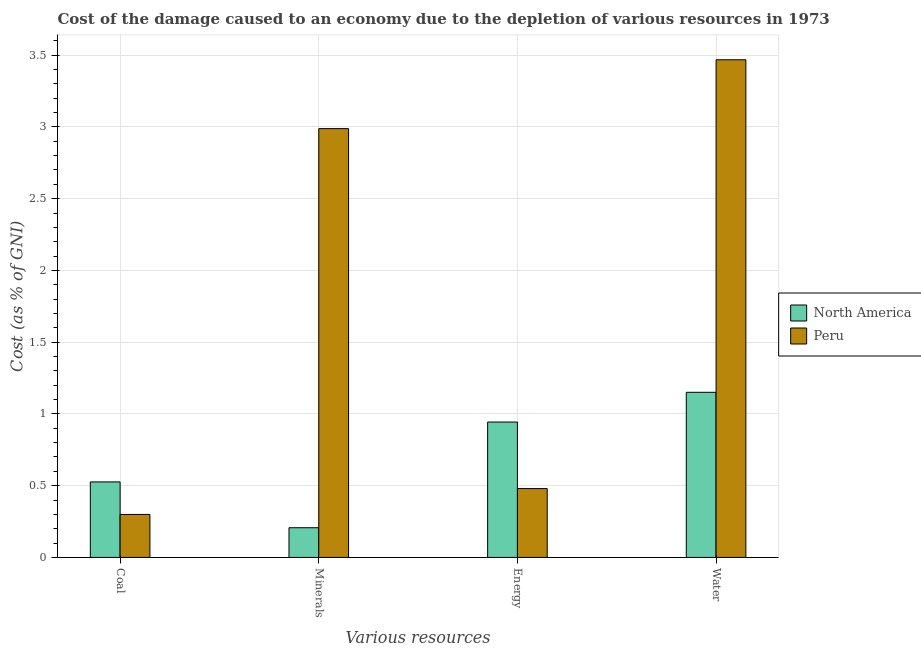How many groups of bars are there?
Provide a short and direct response. 4. Are the number of bars per tick equal to the number of legend labels?
Make the answer very short. Yes. Are the number of bars on each tick of the X-axis equal?
Make the answer very short. Yes. How many bars are there on the 2nd tick from the left?
Offer a terse response. 2. How many bars are there on the 4th tick from the right?
Your response must be concise. 2. What is the label of the 4th group of bars from the left?
Your answer should be compact. Water. What is the cost of damage due to depletion of coal in Peru?
Provide a short and direct response. 0.3. Across all countries, what is the maximum cost of damage due to depletion of minerals?
Ensure brevity in your answer.  2.99. Across all countries, what is the minimum cost of damage due to depletion of minerals?
Provide a succinct answer. 0.21. In which country was the cost of damage due to depletion of energy maximum?
Give a very brief answer. North America. In which country was the cost of damage due to depletion of energy minimum?
Your answer should be very brief. Peru. What is the total cost of damage due to depletion of coal in the graph?
Offer a very short reply. 0.83. What is the difference between the cost of damage due to depletion of energy in North America and that in Peru?
Give a very brief answer. 0.46. What is the difference between the cost of damage due to depletion of minerals in North America and the cost of damage due to depletion of energy in Peru?
Your response must be concise. -0.27. What is the average cost of damage due to depletion of coal per country?
Offer a terse response. 0.41. What is the difference between the cost of damage due to depletion of energy and cost of damage due to depletion of water in North America?
Offer a terse response. -0.21. What is the ratio of the cost of damage due to depletion of energy in North America to that in Peru?
Provide a succinct answer. 1.97. Is the cost of damage due to depletion of coal in North America less than that in Peru?
Give a very brief answer. No. What is the difference between the highest and the second highest cost of damage due to depletion of coal?
Ensure brevity in your answer.  0.23. What is the difference between the highest and the lowest cost of damage due to depletion of coal?
Provide a succinct answer. 0.23. Is the sum of the cost of damage due to depletion of minerals in Peru and North America greater than the maximum cost of damage due to depletion of coal across all countries?
Provide a short and direct response. Yes. Is it the case that in every country, the sum of the cost of damage due to depletion of minerals and cost of damage due to depletion of coal is greater than the sum of cost of damage due to depletion of energy and cost of damage due to depletion of water?
Make the answer very short. No. What does the 2nd bar from the left in Energy represents?
Make the answer very short. Peru. Are the values on the major ticks of Y-axis written in scientific E-notation?
Provide a succinct answer. No. Where does the legend appear in the graph?
Your response must be concise. Center right. How many legend labels are there?
Keep it short and to the point. 2. What is the title of the graph?
Your answer should be very brief. Cost of the damage caused to an economy due to the depletion of various resources in 1973 . Does "Turks and Caicos Islands" appear as one of the legend labels in the graph?
Keep it short and to the point. No. What is the label or title of the X-axis?
Make the answer very short. Various resources. What is the label or title of the Y-axis?
Give a very brief answer. Cost (as % of GNI). What is the Cost (as % of GNI) in North America in Coal?
Ensure brevity in your answer.  0.53. What is the Cost (as % of GNI) in Peru in Coal?
Provide a succinct answer. 0.3. What is the Cost (as % of GNI) of North America in Minerals?
Give a very brief answer. 0.21. What is the Cost (as % of GNI) in Peru in Minerals?
Make the answer very short. 2.99. What is the Cost (as % of GNI) in North America in Energy?
Your answer should be compact. 0.94. What is the Cost (as % of GNI) of Peru in Energy?
Give a very brief answer. 0.48. What is the Cost (as % of GNI) in North America in Water?
Your response must be concise. 1.15. What is the Cost (as % of GNI) of Peru in Water?
Give a very brief answer. 3.47. Across all Various resources, what is the maximum Cost (as % of GNI) in North America?
Keep it short and to the point. 1.15. Across all Various resources, what is the maximum Cost (as % of GNI) in Peru?
Keep it short and to the point. 3.47. Across all Various resources, what is the minimum Cost (as % of GNI) in North America?
Your answer should be very brief. 0.21. Across all Various resources, what is the minimum Cost (as % of GNI) of Peru?
Give a very brief answer. 0.3. What is the total Cost (as % of GNI) of North America in the graph?
Ensure brevity in your answer.  2.83. What is the total Cost (as % of GNI) in Peru in the graph?
Give a very brief answer. 7.24. What is the difference between the Cost (as % of GNI) of North America in Coal and that in Minerals?
Keep it short and to the point. 0.32. What is the difference between the Cost (as % of GNI) in Peru in Coal and that in Minerals?
Keep it short and to the point. -2.69. What is the difference between the Cost (as % of GNI) of North America in Coal and that in Energy?
Provide a succinct answer. -0.42. What is the difference between the Cost (as % of GNI) of Peru in Coal and that in Energy?
Offer a very short reply. -0.18. What is the difference between the Cost (as % of GNI) in North America in Coal and that in Water?
Make the answer very short. -0.62. What is the difference between the Cost (as % of GNI) of Peru in Coal and that in Water?
Provide a short and direct response. -3.17. What is the difference between the Cost (as % of GNI) in North America in Minerals and that in Energy?
Your answer should be very brief. -0.74. What is the difference between the Cost (as % of GNI) in Peru in Minerals and that in Energy?
Offer a very short reply. 2.51. What is the difference between the Cost (as % of GNI) of North America in Minerals and that in Water?
Make the answer very short. -0.94. What is the difference between the Cost (as % of GNI) in Peru in Minerals and that in Water?
Offer a terse response. -0.48. What is the difference between the Cost (as % of GNI) of North America in Energy and that in Water?
Your response must be concise. -0.21. What is the difference between the Cost (as % of GNI) of Peru in Energy and that in Water?
Offer a terse response. -2.99. What is the difference between the Cost (as % of GNI) of North America in Coal and the Cost (as % of GNI) of Peru in Minerals?
Make the answer very short. -2.46. What is the difference between the Cost (as % of GNI) of North America in Coal and the Cost (as % of GNI) of Peru in Energy?
Make the answer very short. 0.05. What is the difference between the Cost (as % of GNI) of North America in Coal and the Cost (as % of GNI) of Peru in Water?
Your response must be concise. -2.94. What is the difference between the Cost (as % of GNI) of North America in Minerals and the Cost (as % of GNI) of Peru in Energy?
Offer a very short reply. -0.27. What is the difference between the Cost (as % of GNI) in North America in Minerals and the Cost (as % of GNI) in Peru in Water?
Offer a terse response. -3.26. What is the difference between the Cost (as % of GNI) of North America in Energy and the Cost (as % of GNI) of Peru in Water?
Offer a terse response. -2.52. What is the average Cost (as % of GNI) in North America per Various resources?
Ensure brevity in your answer.  0.71. What is the average Cost (as % of GNI) in Peru per Various resources?
Ensure brevity in your answer.  1.81. What is the difference between the Cost (as % of GNI) in North America and Cost (as % of GNI) in Peru in Coal?
Your response must be concise. 0.23. What is the difference between the Cost (as % of GNI) of North America and Cost (as % of GNI) of Peru in Minerals?
Offer a terse response. -2.78. What is the difference between the Cost (as % of GNI) in North America and Cost (as % of GNI) in Peru in Energy?
Keep it short and to the point. 0.46. What is the difference between the Cost (as % of GNI) in North America and Cost (as % of GNI) in Peru in Water?
Make the answer very short. -2.32. What is the ratio of the Cost (as % of GNI) in North America in Coal to that in Minerals?
Keep it short and to the point. 2.54. What is the ratio of the Cost (as % of GNI) in Peru in Coal to that in Minerals?
Make the answer very short. 0.1. What is the ratio of the Cost (as % of GNI) of North America in Coal to that in Energy?
Make the answer very short. 0.56. What is the ratio of the Cost (as % of GNI) of Peru in Coal to that in Energy?
Your answer should be compact. 0.62. What is the ratio of the Cost (as % of GNI) in North America in Coal to that in Water?
Your response must be concise. 0.46. What is the ratio of the Cost (as % of GNI) in Peru in Coal to that in Water?
Offer a very short reply. 0.09. What is the ratio of the Cost (as % of GNI) of North America in Minerals to that in Energy?
Provide a succinct answer. 0.22. What is the ratio of the Cost (as % of GNI) in Peru in Minerals to that in Energy?
Your answer should be compact. 6.23. What is the ratio of the Cost (as % of GNI) of North America in Minerals to that in Water?
Keep it short and to the point. 0.18. What is the ratio of the Cost (as % of GNI) in Peru in Minerals to that in Water?
Your answer should be compact. 0.86. What is the ratio of the Cost (as % of GNI) of North America in Energy to that in Water?
Ensure brevity in your answer.  0.82. What is the ratio of the Cost (as % of GNI) of Peru in Energy to that in Water?
Offer a very short reply. 0.14. What is the difference between the highest and the second highest Cost (as % of GNI) in North America?
Provide a succinct answer. 0.21. What is the difference between the highest and the second highest Cost (as % of GNI) in Peru?
Offer a very short reply. 0.48. What is the difference between the highest and the lowest Cost (as % of GNI) of North America?
Make the answer very short. 0.94. What is the difference between the highest and the lowest Cost (as % of GNI) of Peru?
Your answer should be very brief. 3.17. 